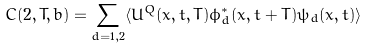<formula> <loc_0><loc_0><loc_500><loc_500>C ( 2 , T , b ) = \sum _ { d = 1 , 2 } \langle U ^ { Q } ( { x } , t , T ) \phi ^ { * } _ { d } ( { x } , t + T ) \psi _ { d } ( { x } , t ) \rangle</formula> 